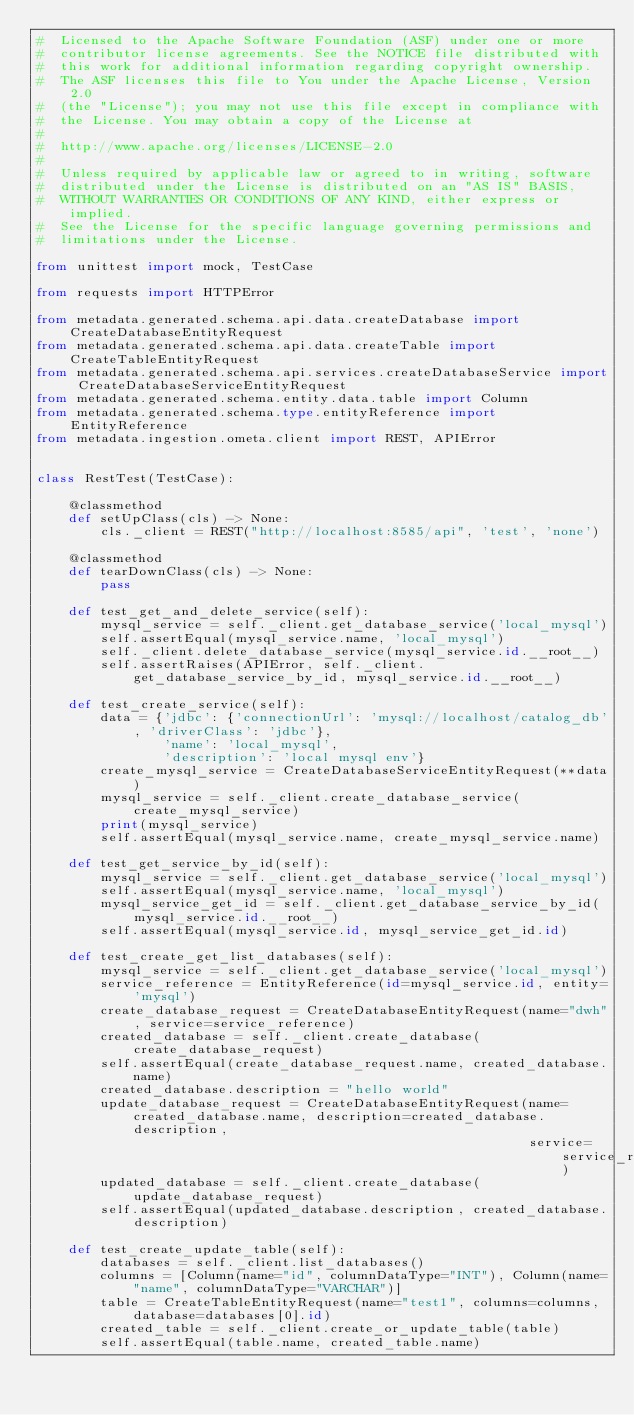<code> <loc_0><loc_0><loc_500><loc_500><_Python_>#  Licensed to the Apache Software Foundation (ASF) under one or more
#  contributor license agreements. See the NOTICE file distributed with
#  this work for additional information regarding copyright ownership.
#  The ASF licenses this file to You under the Apache License, Version 2.0
#  (the "License"); you may not use this file except in compliance with
#  the License. You may obtain a copy of the License at
#
#  http://www.apache.org/licenses/LICENSE-2.0
#
#  Unless required by applicable law or agreed to in writing, software
#  distributed under the License is distributed on an "AS IS" BASIS,
#  WITHOUT WARRANTIES OR CONDITIONS OF ANY KIND, either express or implied.
#  See the License for the specific language governing permissions and
#  limitations under the License.

from unittest import mock, TestCase

from requests import HTTPError

from metadata.generated.schema.api.data.createDatabase import CreateDatabaseEntityRequest
from metadata.generated.schema.api.data.createTable import CreateTableEntityRequest
from metadata.generated.schema.api.services.createDatabaseService import CreateDatabaseServiceEntityRequest
from metadata.generated.schema.entity.data.table import Column
from metadata.generated.schema.type.entityReference import EntityReference
from metadata.ingestion.ometa.client import REST, APIError


class RestTest(TestCase):

    @classmethod
    def setUpClass(cls) -> None:
        cls._client = REST("http://localhost:8585/api", 'test', 'none')

    @classmethod
    def tearDownClass(cls) -> None:
        pass

    def test_get_and_delete_service(self):
        mysql_service = self._client.get_database_service('local_mysql')
        self.assertEqual(mysql_service.name, 'local_mysql')
        self._client.delete_database_service(mysql_service.id.__root__)
        self.assertRaises(APIError, self._client.get_database_service_by_id, mysql_service.id.__root__)

    def test_create_service(self):
        data = {'jdbc': {'connectionUrl': 'mysql://localhost/catalog_db', 'driverClass': 'jdbc'},
                'name': 'local_mysql',
                'description': 'local mysql env'}
        create_mysql_service = CreateDatabaseServiceEntityRequest(**data)
        mysql_service = self._client.create_database_service(create_mysql_service)
        print(mysql_service)
        self.assertEqual(mysql_service.name, create_mysql_service.name)

    def test_get_service_by_id(self):
        mysql_service = self._client.get_database_service('local_mysql')
        self.assertEqual(mysql_service.name, 'local_mysql')
        mysql_service_get_id = self._client.get_database_service_by_id(mysql_service.id.__root__)
        self.assertEqual(mysql_service.id, mysql_service_get_id.id)

    def test_create_get_list_databases(self):
        mysql_service = self._client.get_database_service('local_mysql')
        service_reference = EntityReference(id=mysql_service.id, entity='mysql')
        create_database_request = CreateDatabaseEntityRequest(name="dwh", service=service_reference)
        created_database = self._client.create_database(create_database_request)
        self.assertEqual(create_database_request.name, created_database.name)
        created_database.description = "hello world"
        update_database_request = CreateDatabaseEntityRequest(name=created_database.name, description=created_database.description,
                                                              service=service_reference)
        updated_database = self._client.create_database(update_database_request)
        self.assertEqual(updated_database.description, created_database.description)

    def test_create_update_table(self):
        databases = self._client.list_databases()
        columns = [Column(name="id", columnDataType="INT"), Column(name="name", columnDataType="VARCHAR")]
        table = CreateTableEntityRequest(name="test1", columns=columns, database=databases[0].id)
        created_table = self._client.create_or_update_table(table)
        self.assertEqual(table.name, created_table.name)
</code> 